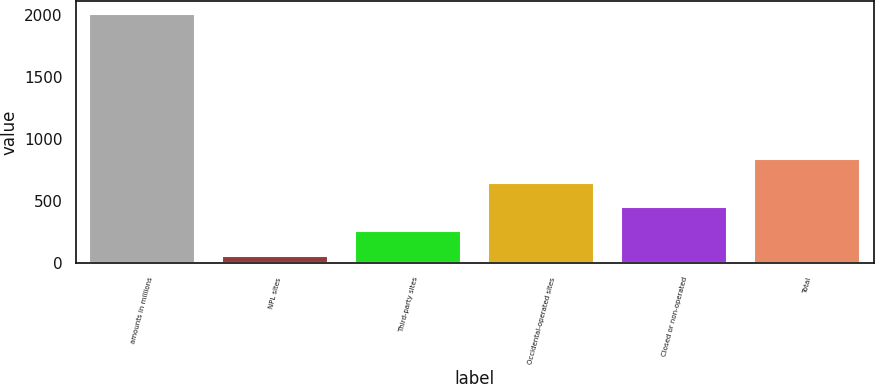Convert chart to OTSL. <chart><loc_0><loc_0><loc_500><loc_500><bar_chart><fcel>amounts in millions<fcel>NPL sites<fcel>Third-party sites<fcel>Occidental-operated sites<fcel>Closed or non-operated<fcel>Total<nl><fcel>2011<fcel>63<fcel>257.8<fcel>647.4<fcel>452.6<fcel>842.2<nl></chart> 